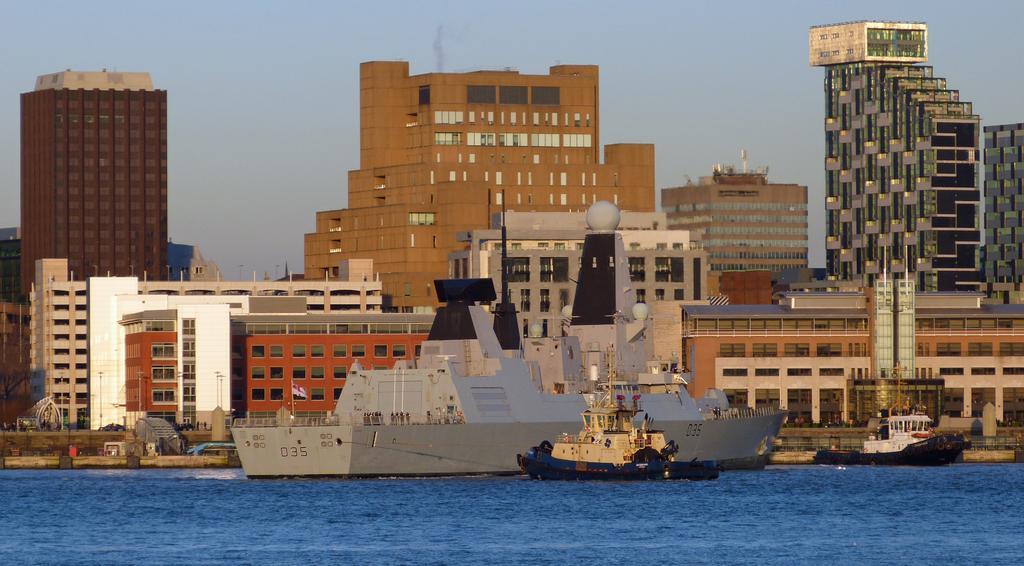Can you describe this image briefly? In this picture we can see there are ships on the water and behind the ships there are buildings and a sky. 